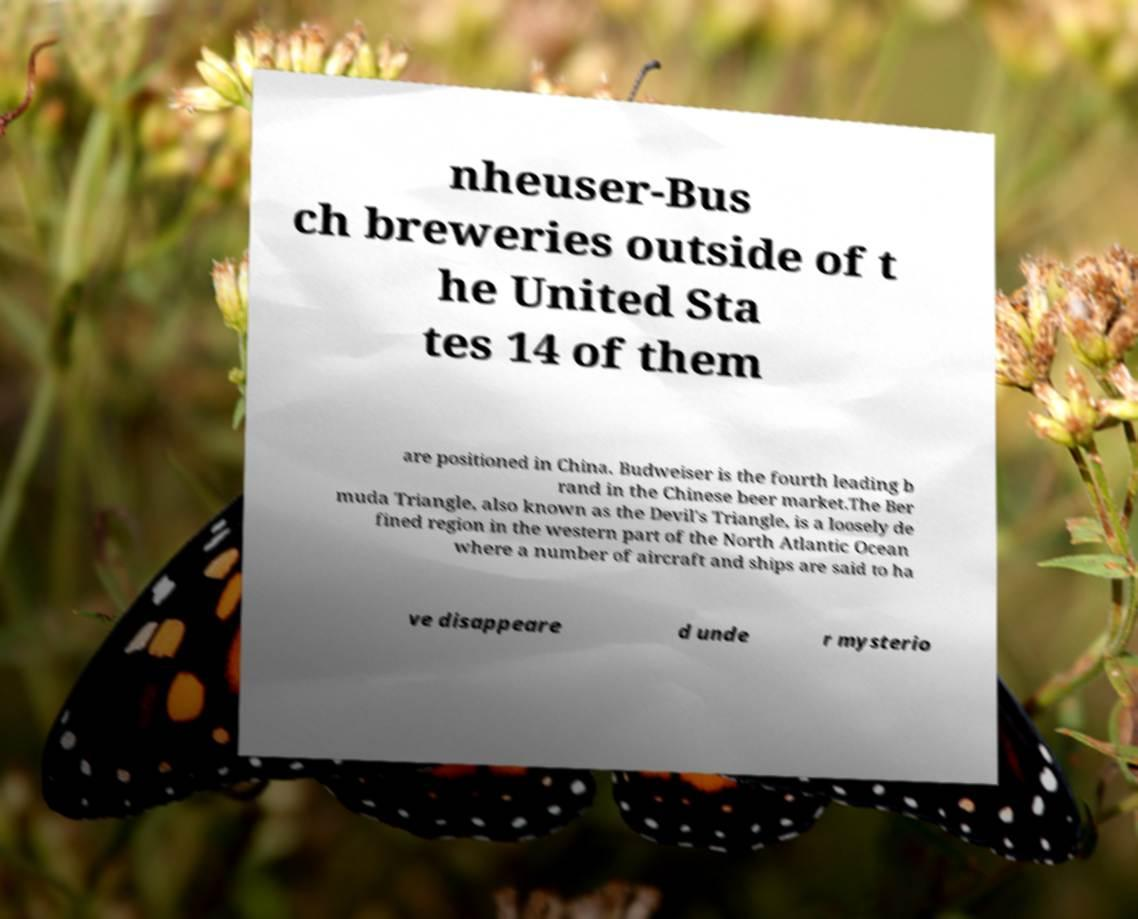Could you assist in decoding the text presented in this image and type it out clearly? nheuser-Bus ch breweries outside of t he United Sta tes 14 of them are positioned in China. Budweiser is the fourth leading b rand in the Chinese beer market.The Ber muda Triangle, also known as the Devil's Triangle, is a loosely de fined region in the western part of the North Atlantic Ocean where a number of aircraft and ships are said to ha ve disappeare d unde r mysterio 